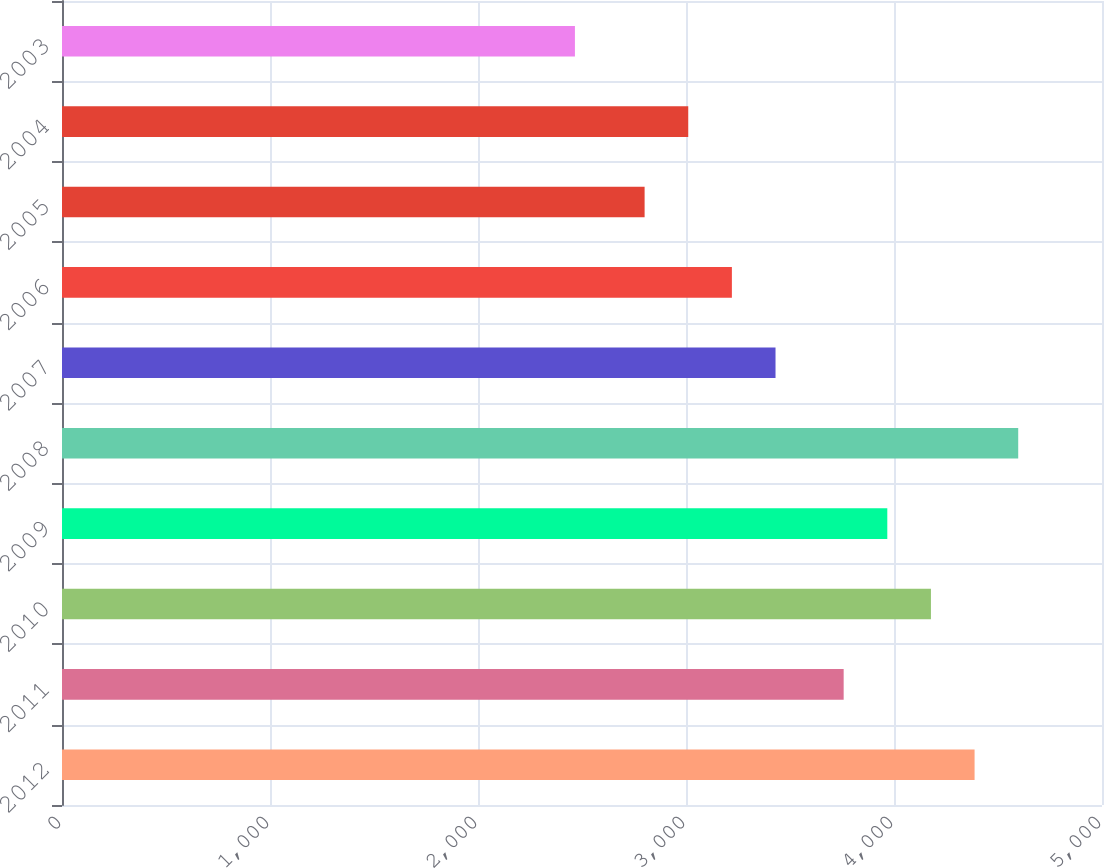Convert chart. <chart><loc_0><loc_0><loc_500><loc_500><bar_chart><fcel>2012<fcel>2011<fcel>2010<fcel>2009<fcel>2008<fcel>2007<fcel>2006<fcel>2005<fcel>2004<fcel>2003<nl><fcel>4387.4<fcel>3758<fcel>4177.6<fcel>3967.8<fcel>4597.2<fcel>3430.4<fcel>3220.6<fcel>2801<fcel>3010.8<fcel>2466<nl></chart> 